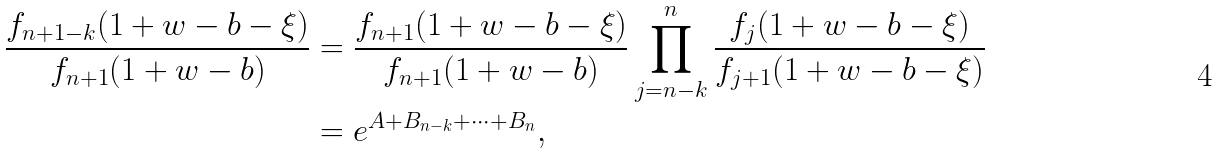Convert formula to latex. <formula><loc_0><loc_0><loc_500><loc_500>\frac { f _ { n + 1 - k } ( 1 + w - b - \xi ) } { f _ { n + 1 } ( 1 + w - b ) } & = \frac { f _ { n + 1 } ( 1 + w - b - \xi ) } { f _ { n + 1 } ( 1 + w - b ) } \prod _ { j = n - k } ^ { n } \frac { f _ { j } ( 1 + w - b - \xi ) } { f _ { j + 1 } ( 1 + w - b - \xi ) } \\ & = e ^ { A + B _ { n - k } + \cdots + B _ { n } } ,</formula> 